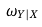Convert formula to latex. <formula><loc_0><loc_0><loc_500><loc_500>\omega _ { Y | X }</formula> 